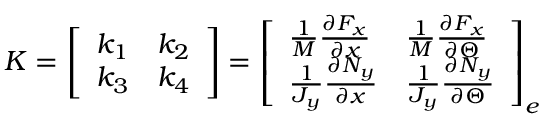<formula> <loc_0><loc_0><loc_500><loc_500>K = \left [ \begin{array} { l l } { k _ { 1 } } & { k _ { 2 } } \\ { k _ { 3 } } & { k _ { 4 } } \end{array} \right ] = \left [ \begin{array} { l l } { \frac { 1 } { M } \frac { \partial F _ { x } } { \partial x } } & { \frac { 1 } { M } \frac { \partial F _ { x } } { \partial \Theta } } \\ { \frac { 1 } { J _ { y } } \frac { \partial N _ { y } } { \partial x } } & { \frac { 1 } { J _ { y } } \frac { \partial N _ { y } } { \partial \Theta } } \end{array} \right ] _ { e }</formula> 